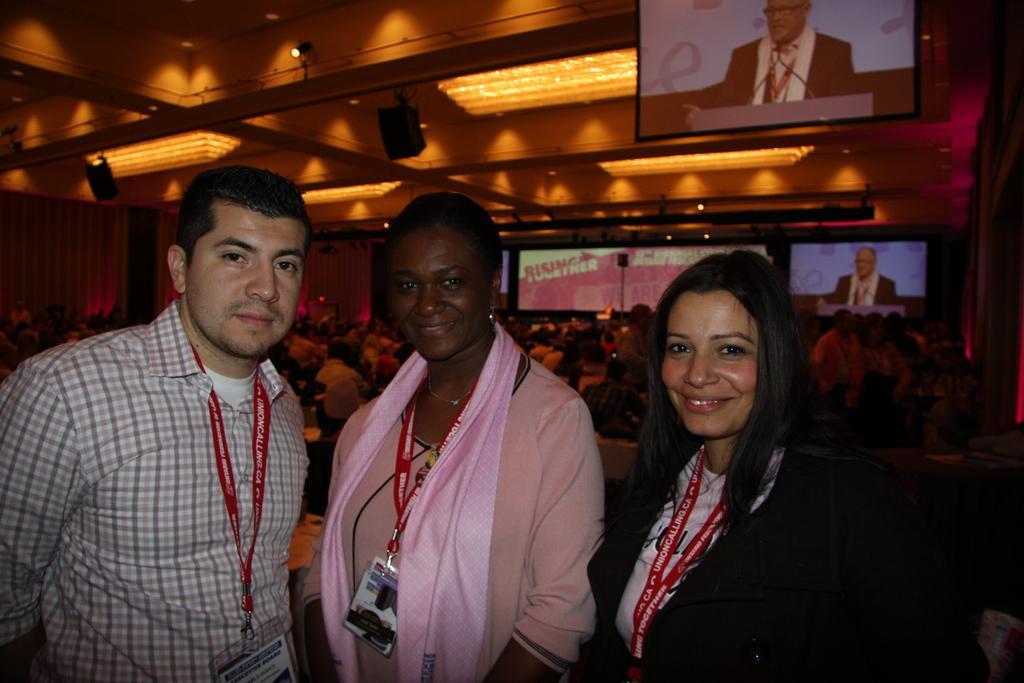Could you give a brief overview of what you see in this image? In this picture we can see two women standing and smiling. There is a person standing on the left side. We can see some people sitting on the chair and a few people are standing on the right side. We can see a few screens at the back. There is a person visible on these screens. We can see a few lights and other objects on top of the picture. 